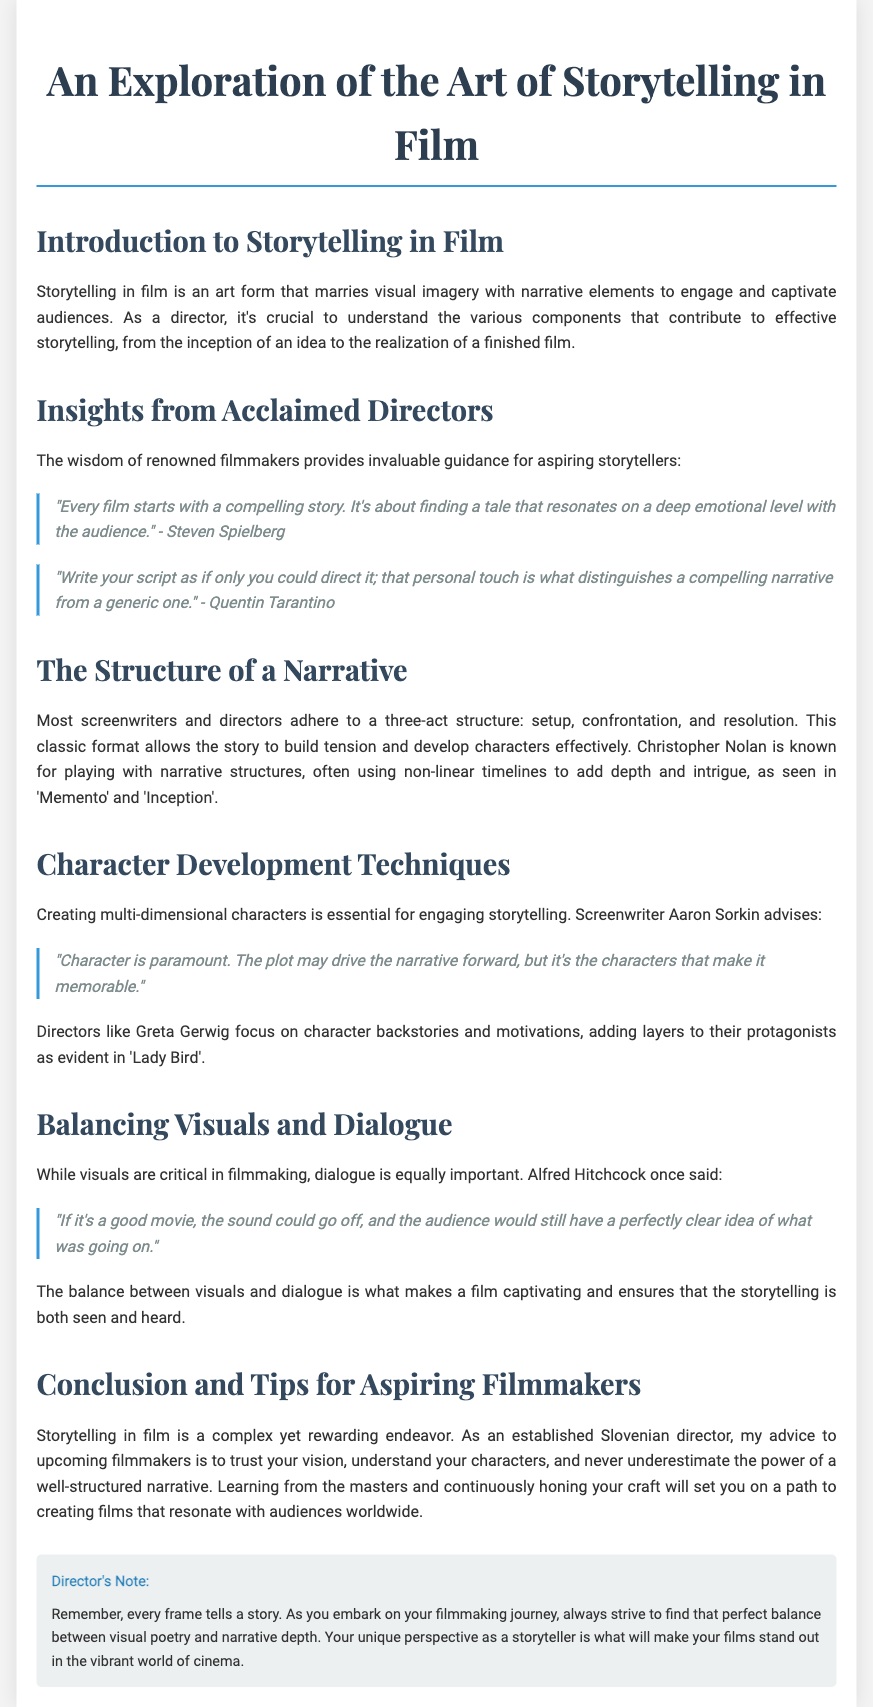What is the main art form discussed in the document? The document explores storytelling in film, emphasizing the combination of visual imagery and narrative elements.
Answer: storytelling in film Who is quoted as saying, "Character is paramount"? This quote comes from screenwriter Aaron Sorkin, highlighting the importance of character in storytelling.
Answer: Aaron Sorkin What structure do most screenwriters adhere to? The document mentions the three-act structure consisting of setup, confrontation, and resolution.
Answer: three-act structure Which director is known for non-linear timelines? Christopher Nolan is recognized for his experimentation with non-linear narrative structures in films.
Answer: Christopher Nolan What does Alfred Hitchcock imply about the importance of visuals in films? Hitchcock suggests that a good movie can convey its story visually, even without sound.
Answer: sound could go off What is emphasized as essential for engaging storytelling? The creation of multi-dimensional characters is indicated as vital for captivating narratives.
Answer: multi-dimensional characters What should aspiring filmmakers trust according to the director's advice? The director advises upcoming filmmakers to trust their vision during the filmmaking process.
Answer: their vision What film is mentioned in relation to character backstories? The film 'Lady Bird' is exemplified for its focus on character backstories and motivations.
Answer: Lady Bird What does the director note about framing in storytelling? The director's note emphasizes that every frame in filmmaking tells a story.
Answer: every frame tells a story 